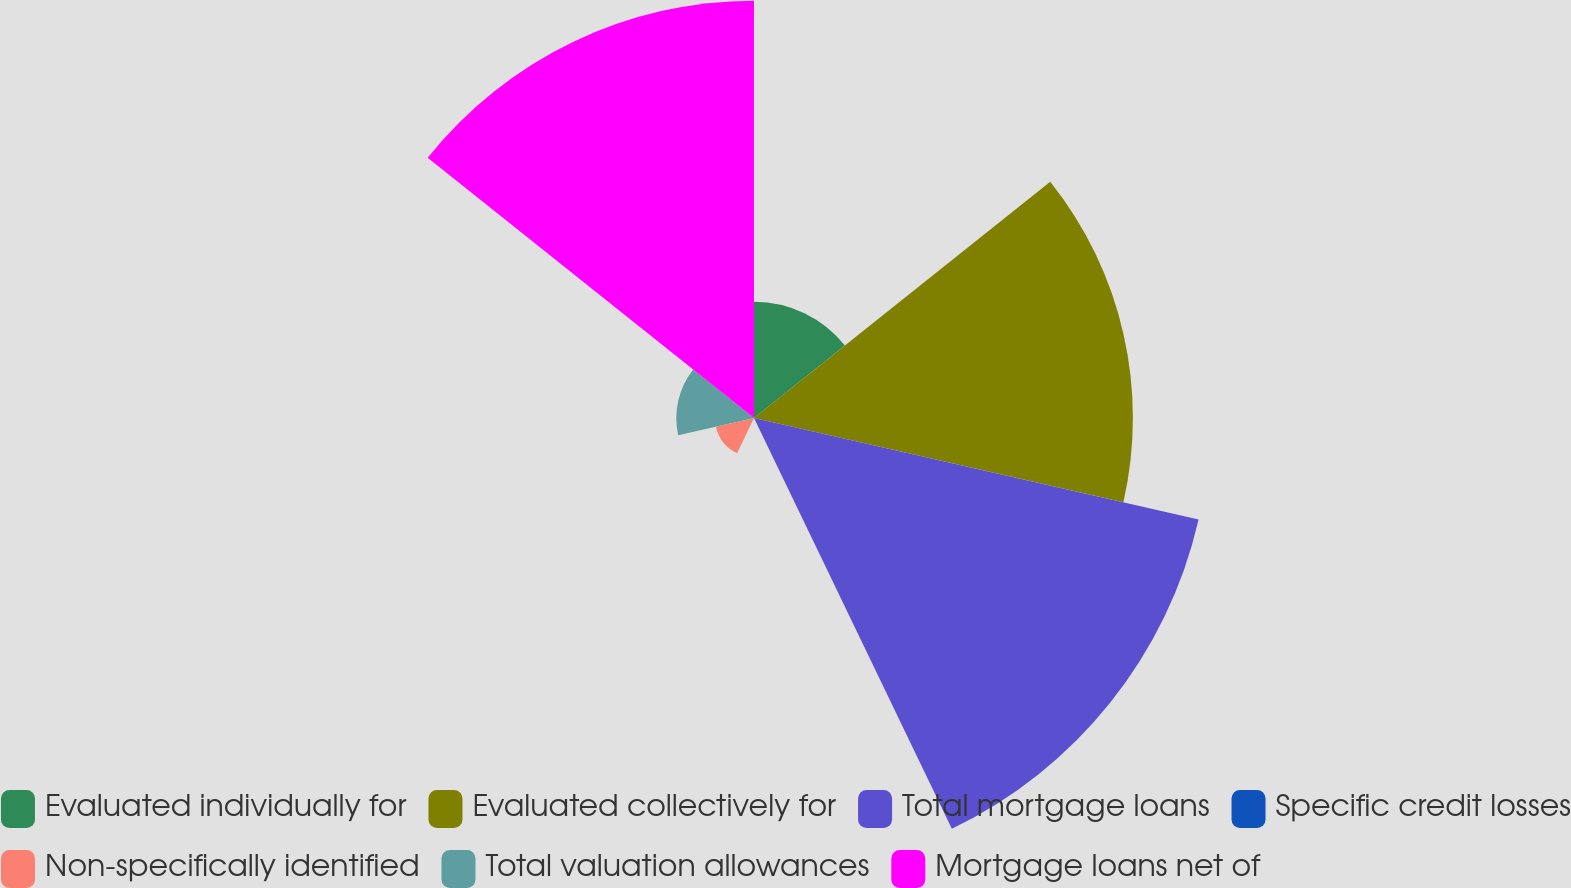Convert chart to OTSL. <chart><loc_0><loc_0><loc_500><loc_500><pie_chart><fcel>Evaluated individually for<fcel>Evaluated collectively for<fcel>Total mortgage loans<fcel>Specific credit losses<fcel>Non-specifically identified<fcel>Total valuation allowances<fcel>Mortgage loans net of<nl><fcel>7.82%<fcel>25.5%<fcel>30.69%<fcel>0.04%<fcel>2.63%<fcel>5.23%<fcel>28.09%<nl></chart> 